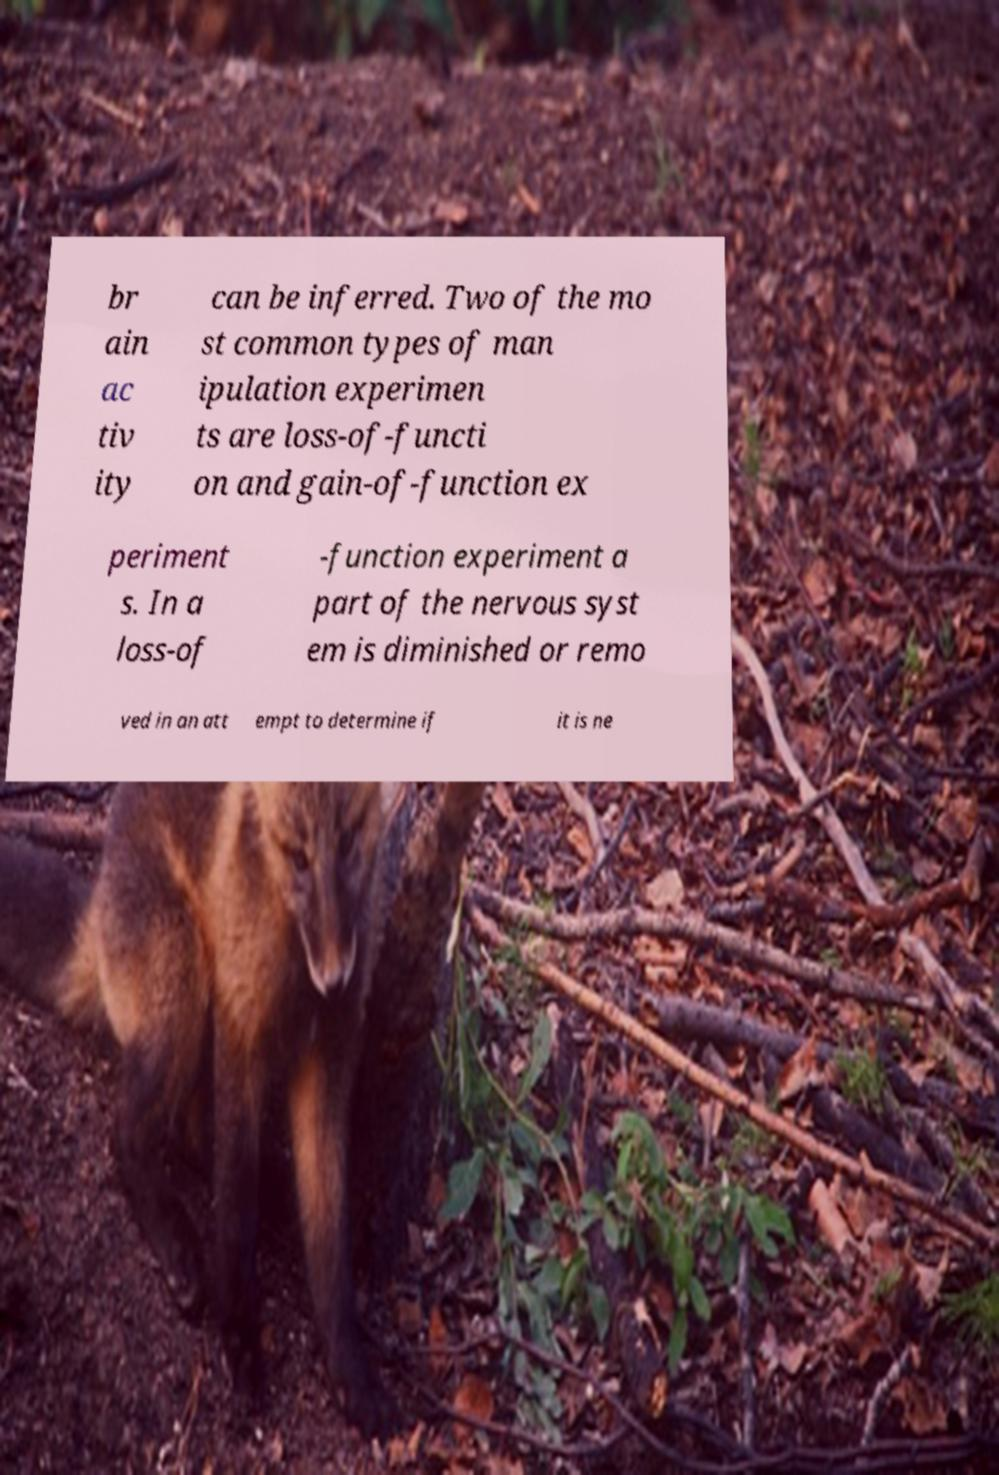I need the written content from this picture converted into text. Can you do that? br ain ac tiv ity can be inferred. Two of the mo st common types of man ipulation experimen ts are loss-of-functi on and gain-of-function ex periment s. In a loss-of -function experiment a part of the nervous syst em is diminished or remo ved in an att empt to determine if it is ne 